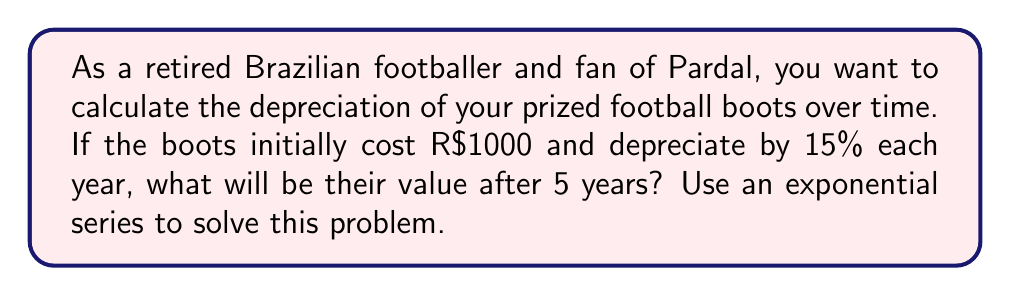Can you answer this question? Let's approach this step-by-step using an exponential series:

1) The initial value of the boots is R$1000.

2) Each year, the value decreases by 15%, which means it retains 85% (or 0.85) of its value from the previous year.

3) We can represent this as an exponential function:
   $$V(t) = 1000 * (0.85)^t$$
   where $V(t)$ is the value after $t$ years.

4) We want to find the value after 5 years, so we substitute $t=5$:
   $$V(5) = 1000 * (0.85)^5$$

5) Now let's calculate:
   $$V(5) = 1000 * 0.4437$$
   $$V(5) = 443.70$$

6) Rounding to the nearest real (R$):
   $$V(5) \approx R$444$$

Therefore, after 5 years, the football boots will be worth approximately R$444.
Answer: R$444 